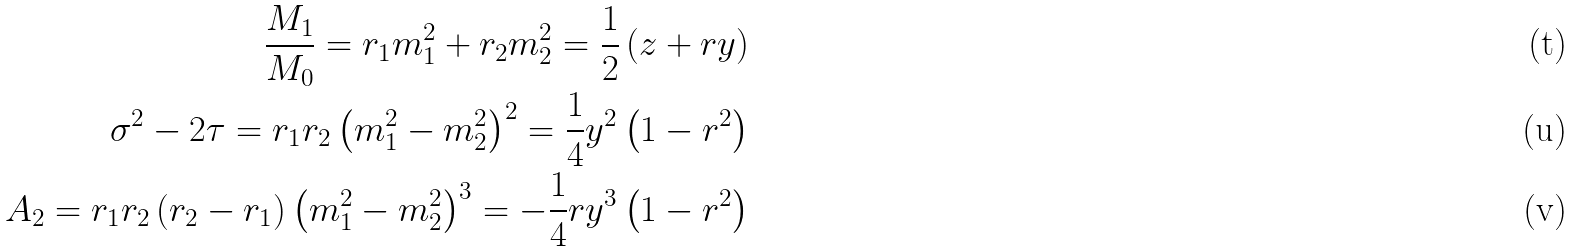<formula> <loc_0><loc_0><loc_500><loc_500>\frac { M _ { 1 } } { M _ { 0 } } = r _ { 1 } m _ { 1 } ^ { 2 } + r _ { 2 } m _ { 2 } ^ { 2 } = \frac { 1 } { 2 } \left ( z + r y \right ) \\ \sigma ^ { 2 } - 2 \tau = r _ { 1 } r _ { 2 } \left ( m _ { 1 } ^ { 2 } - m _ { 2 } ^ { 2 } \right ) ^ { 2 } = \frac { 1 } { 4 } y ^ { 2 } \left ( 1 - r ^ { 2 } \right ) \\ A _ { 2 } = r _ { 1 } r _ { 2 } \left ( r _ { 2 } - r _ { 1 } \right ) \left ( m _ { 1 } ^ { 2 } - m _ { 2 } ^ { 2 } \right ) ^ { 3 } = - \frac { 1 } { 4 } r y ^ { 3 } \left ( 1 - r ^ { 2 } \right )</formula> 